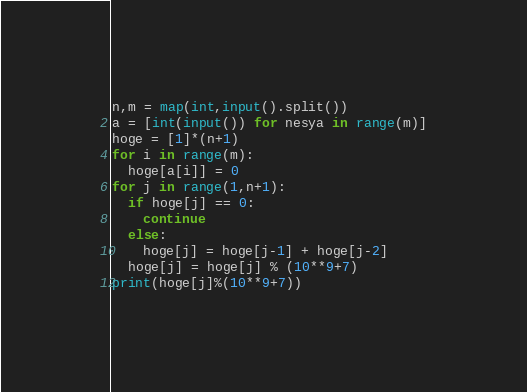Convert code to text. <code><loc_0><loc_0><loc_500><loc_500><_Python_>n,m = map(int,input().split())
a = [int(input()) for nesya in range(m)]
hoge = [1]*(n+1)
for i in range(m):
  hoge[a[i]] = 0
for j in range(1,n+1):
  if hoge[j] == 0:
    continue
  else:
    hoge[j] = hoge[j-1] + hoge[j-2]
  hoge[j] = hoge[j] % (10**9+7)
print(hoge[j]%(10**9+7))</code> 